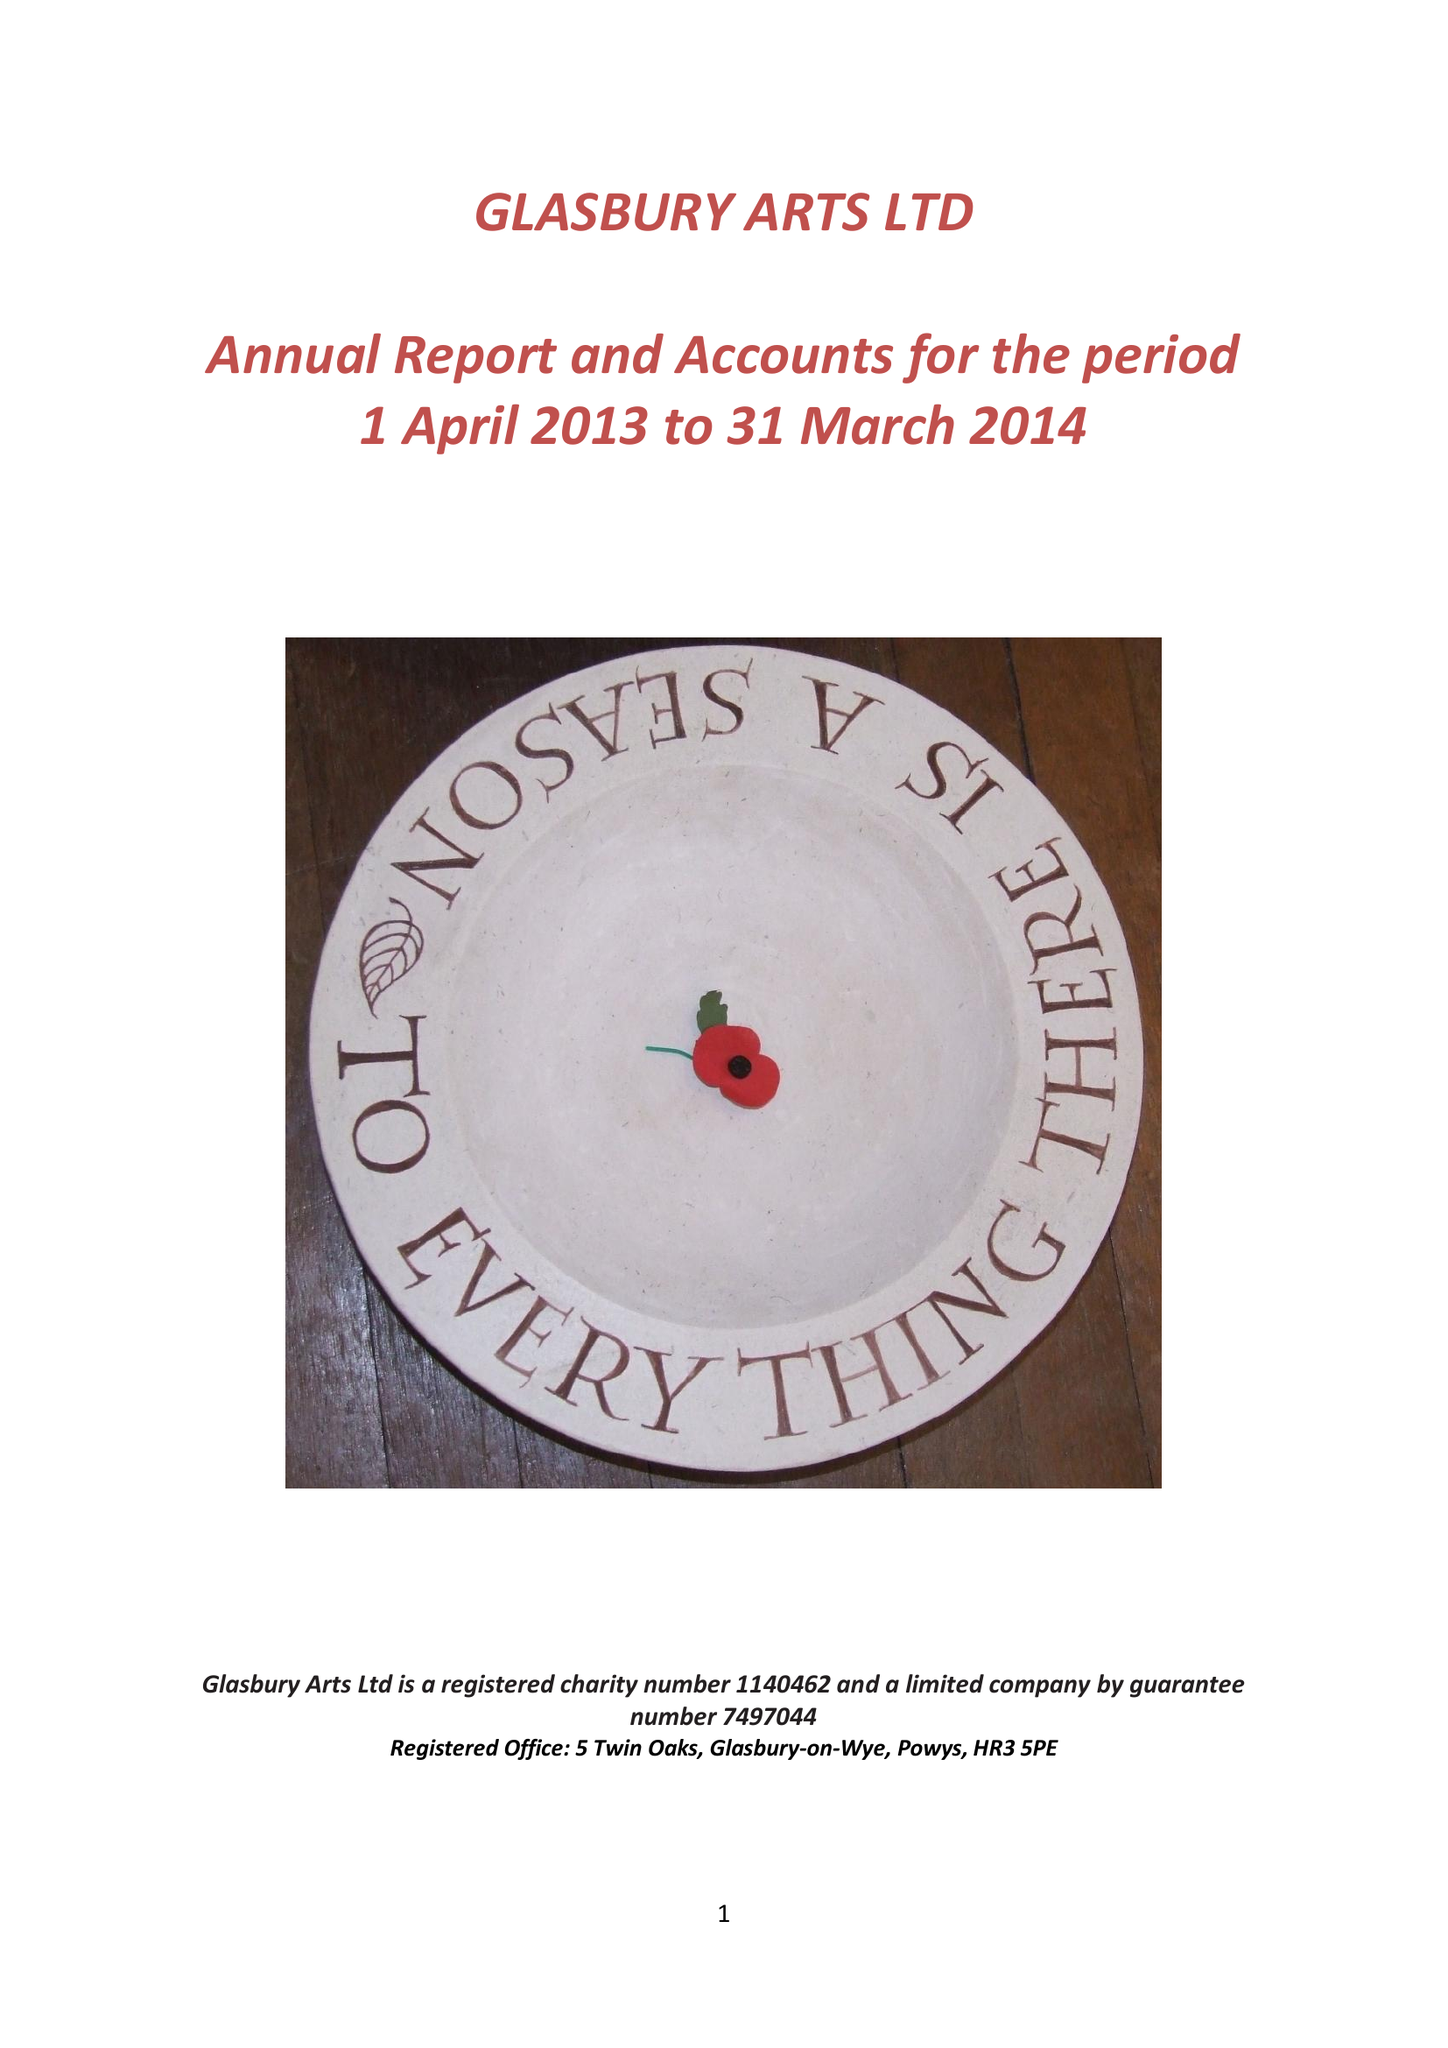What is the value for the report_date?
Answer the question using a single word or phrase. 2014-03-31 